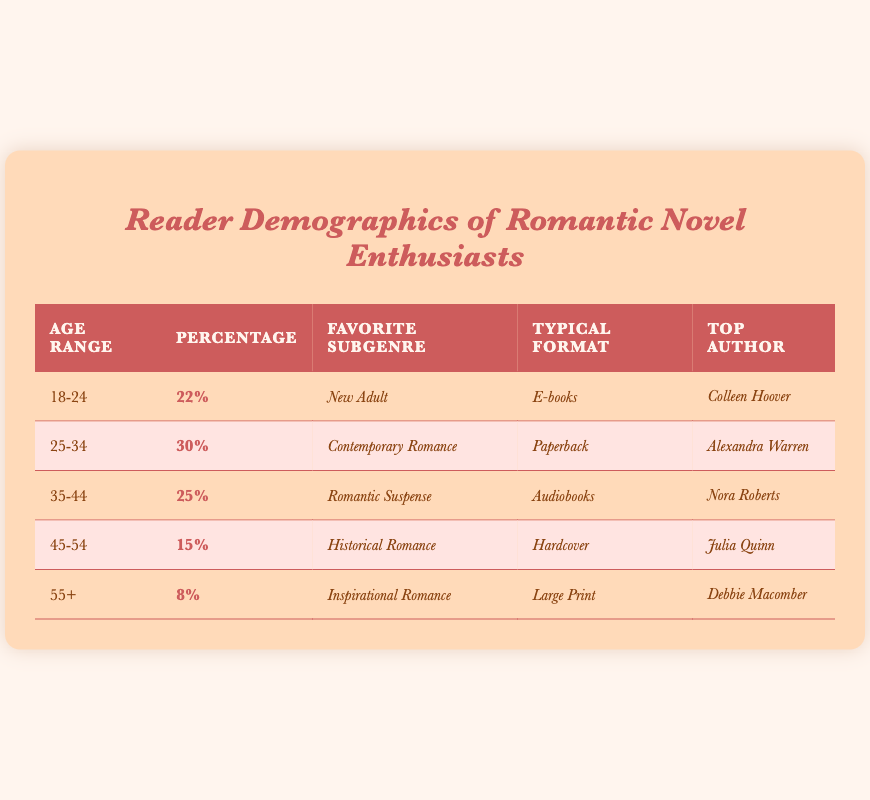What percentage of readers are aged 25-34? The table indicates a specific percentage for the age range of 25-34, which is listed as 30%.
Answer: 30% Which subgenre is most popular among readers aged 18-24? According to the table, the favorite subgenre for the age group 18-24 is listed as New Adult.
Answer: New Adult What is the typical format preferred by readers aged 45-54? The typical format for the age range 45-54 is stated in the table as Hardcover.
Answer: Hardcover Is Nora Roberts the top author for readers aged 35-44? The table shows that the top author for the age range 35-44 is Nora Roberts, confirming the statement as true.
Answer: Yes What is the average percentage of readers aged 35 and younger? To find the average, add the percentages for the age ranges 18-24 (22%) and 25-34 (30%) for a sum of 52%, then divide by 2, yielding an average of 26%.
Answer: 26% Which age range has the lowest percentage of readers? The table indicates that the age range 55+ has the lowest percentage, which is listed as 8%.
Answer: 55+ If the percentages of age groups are summed together, what should the total be? The total of all age group percentages from the table is calculated as follows: 22% + 30% + 25% + 15% + 8% = 100%.
Answer: 100% Is the typical format for readers in the 35-44 age range Audiobooks? The table confirms that the typical format for readers aged 35-44 is indeed Audiobooks.
Answer: Yes Which top author corresponds to the readers' favorite subgenre of Historical Romance? The table shows that readers of Historial Romance have Julia Quinn as their top author.
Answer: Julia Quinn How does the percentage of readers who prefer Large Print compare to those who prefer E-books? Readers who prefer Large Print (8%) have a lower percentage compared to those who prefer E-books (22%), showing a difference of 14%.
Answer: 14% less 